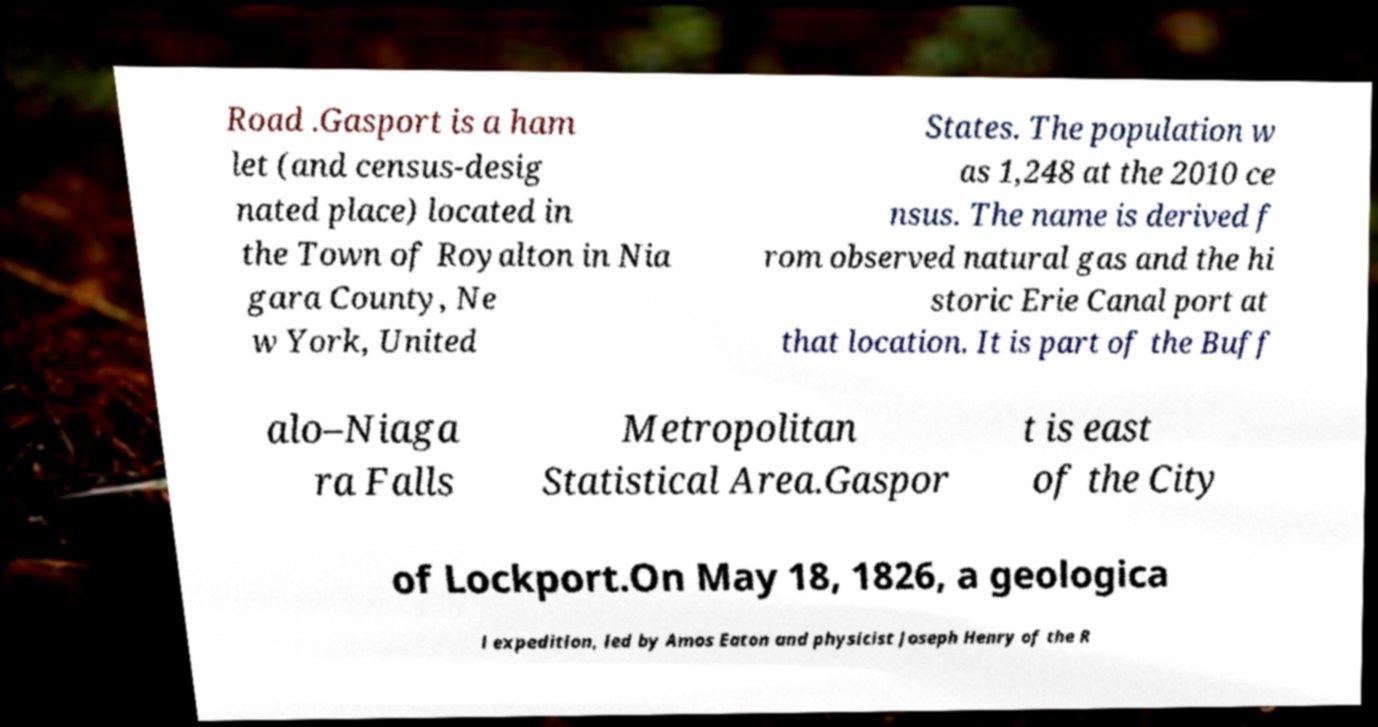Can you accurately transcribe the text from the provided image for me? Road .Gasport is a ham let (and census-desig nated place) located in the Town of Royalton in Nia gara County, Ne w York, United States. The population w as 1,248 at the 2010 ce nsus. The name is derived f rom observed natural gas and the hi storic Erie Canal port at that location. It is part of the Buff alo–Niaga ra Falls Metropolitan Statistical Area.Gaspor t is east of the City of Lockport.On May 18, 1826, a geologica l expedition, led by Amos Eaton and physicist Joseph Henry of the R 